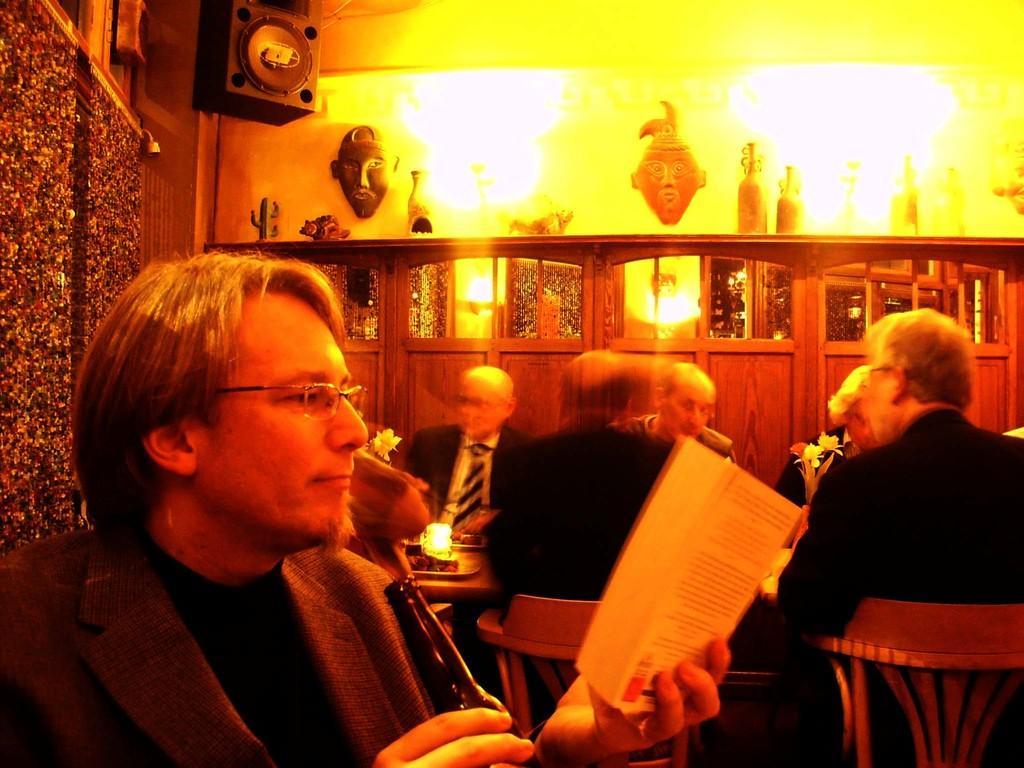Describe this image in one or two sentences. In this image I can see the group of people sitting and wearing the blazers. I can see one person holding the book and wearing the specs. In the background I can see many decorative objects, lights and the wall. I can also see the sound box. 